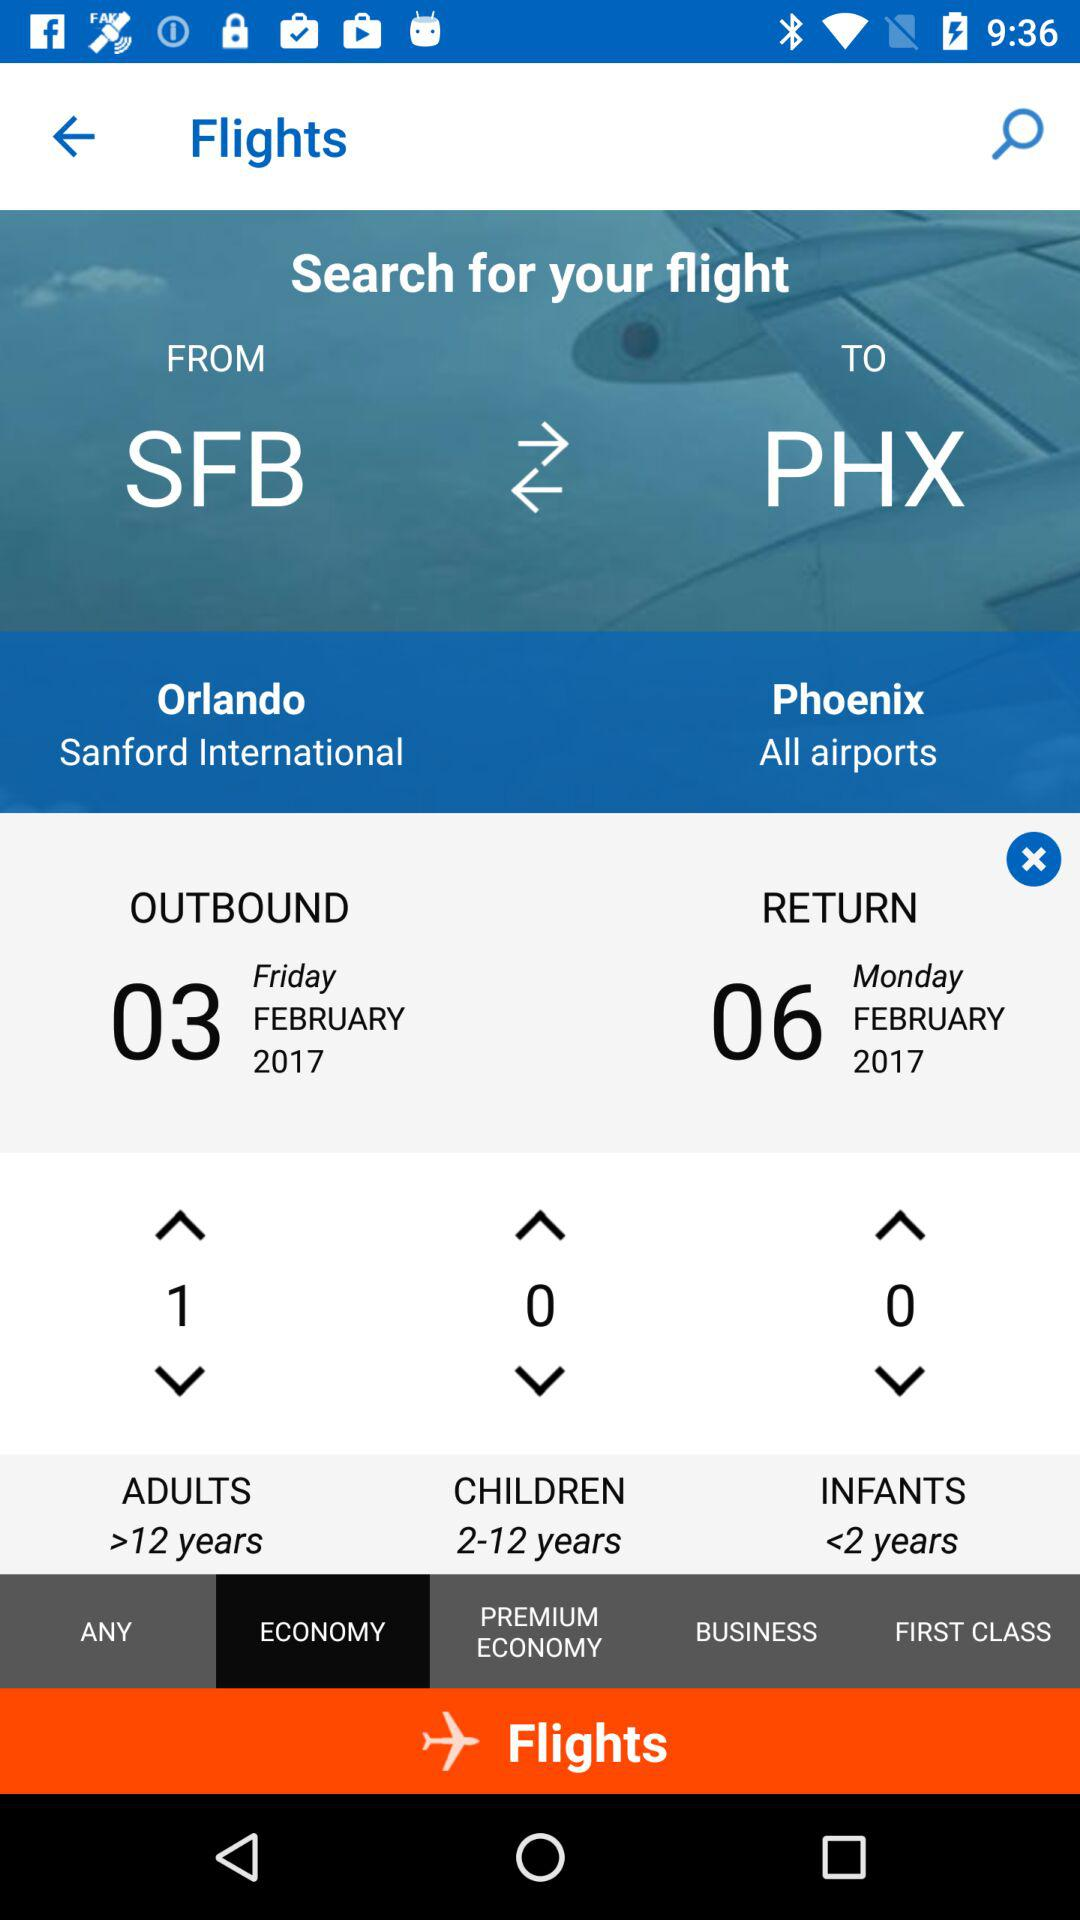What is the return date? The return date is Monday, February 6, 2017. 